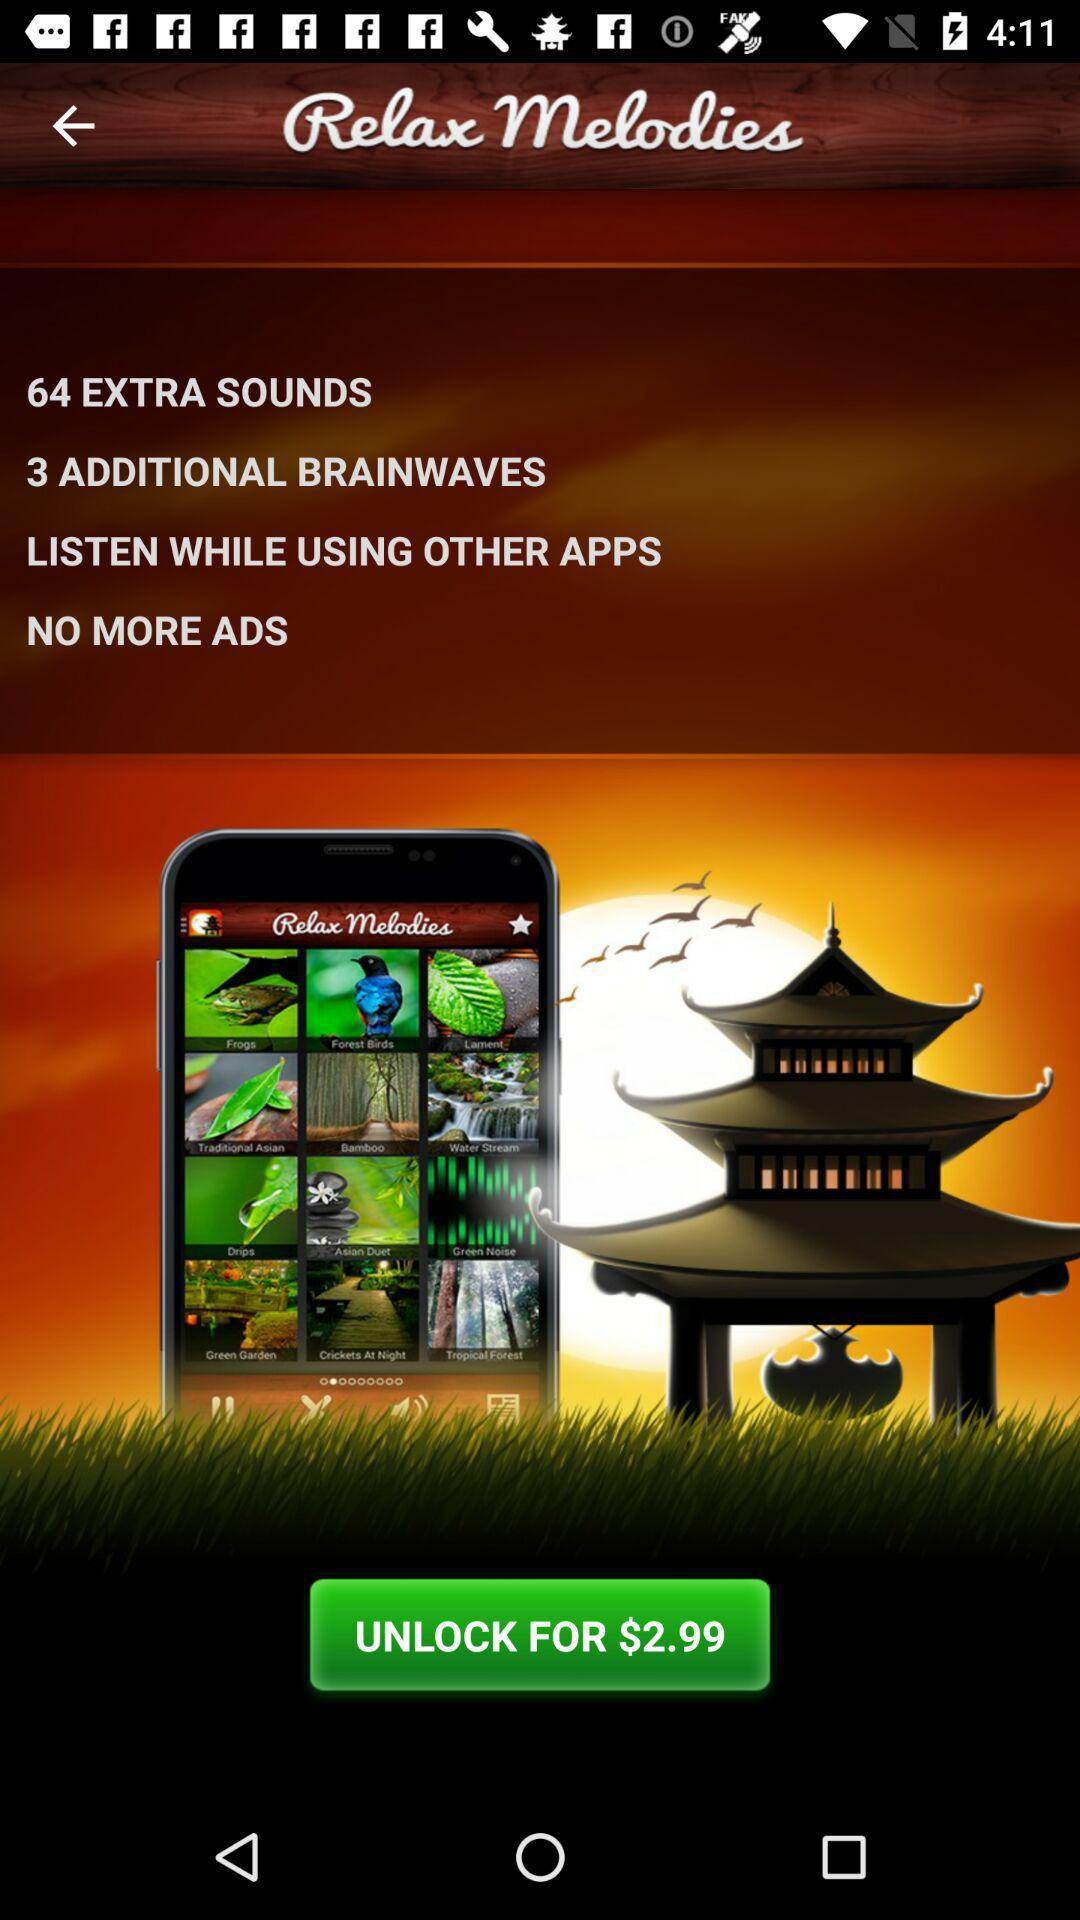How many additional brainwaves are there? There are three additional brainwaves. 